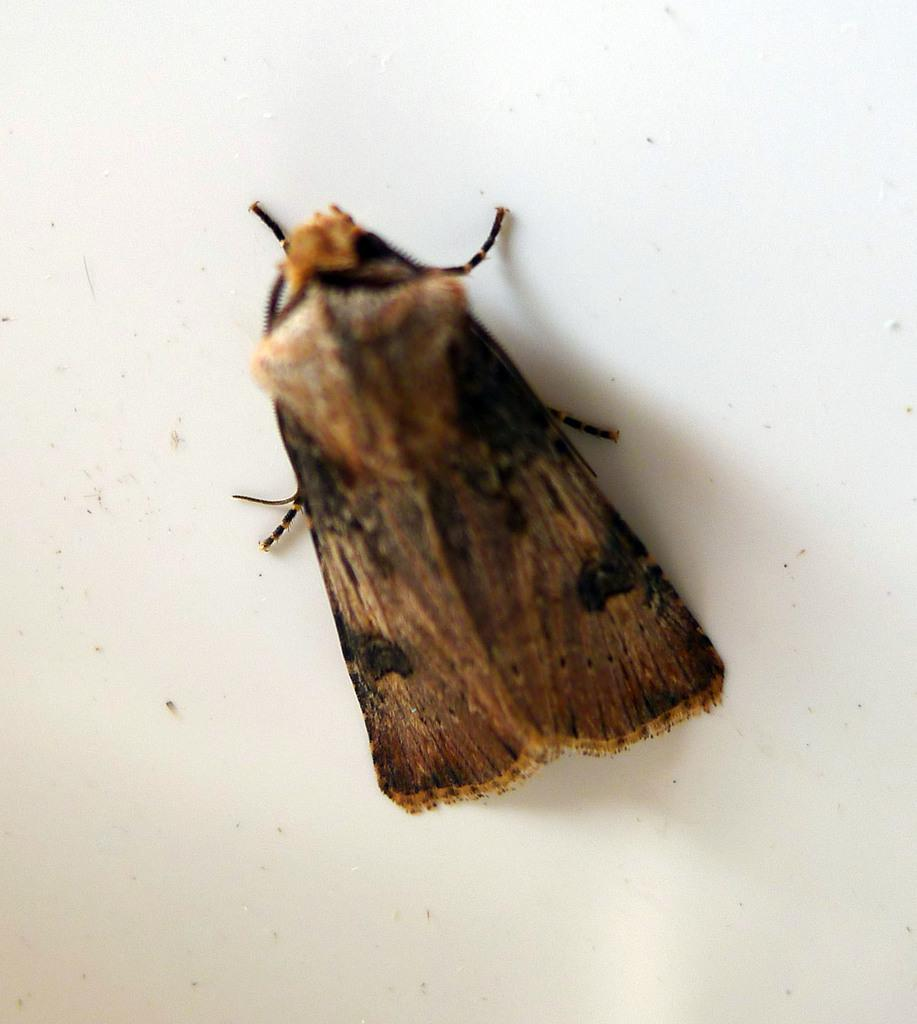What type of creature is present in the image? There is an insect in the image. Where is the insect located in the image? The insect is on the surface. What type of cup is the insect using to perform its hobbies in the image? There is no cup present in the image, and insects do not have hobbies. 